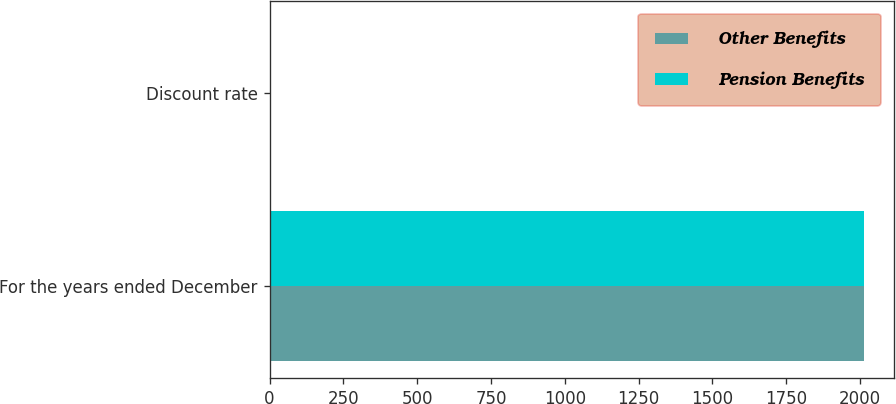Convert chart. <chart><loc_0><loc_0><loc_500><loc_500><stacked_bar_chart><ecel><fcel>For the years ended December<fcel>Discount rate<nl><fcel>Other Benefits<fcel>2014<fcel>4.5<nl><fcel>Pension Benefits<fcel>2014<fcel>4.5<nl></chart> 